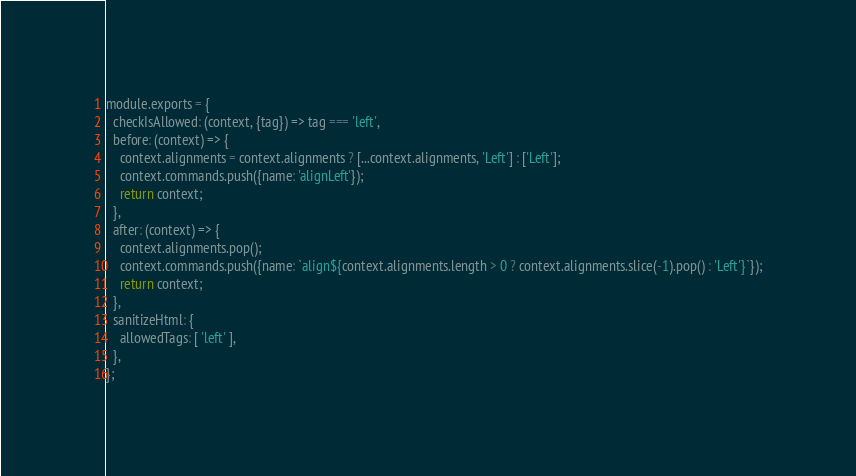Convert code to text. <code><loc_0><loc_0><loc_500><loc_500><_JavaScript_>module.exports = {
  checkIsAllowed: (context, {tag}) => tag === 'left',
  before: (context) => {
    context.alignments = context.alignments ? [...context.alignments, 'Left'] : ['Left'];
    context.commands.push({name: 'alignLeft'});
    return context;
  },
  after: (context) => {
    context.alignments.pop();
    context.commands.push({name: `align${context.alignments.length > 0 ? context.alignments.slice(-1).pop() : 'Left'}`});
    return context;
  },
  sanitizeHtml: {
    allowedTags: [ 'left' ],
  },
};</code> 